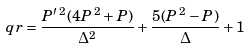Convert formula to latex. <formula><loc_0><loc_0><loc_500><loc_500>q r = \frac { P ^ { \prime } \, ^ { 2 } ( 4 P \, ^ { 2 } + P ) } { \Delta ^ { 2 } } + \frac { 5 ( P \, ^ { 2 } - P ) } { \Delta } + 1</formula> 